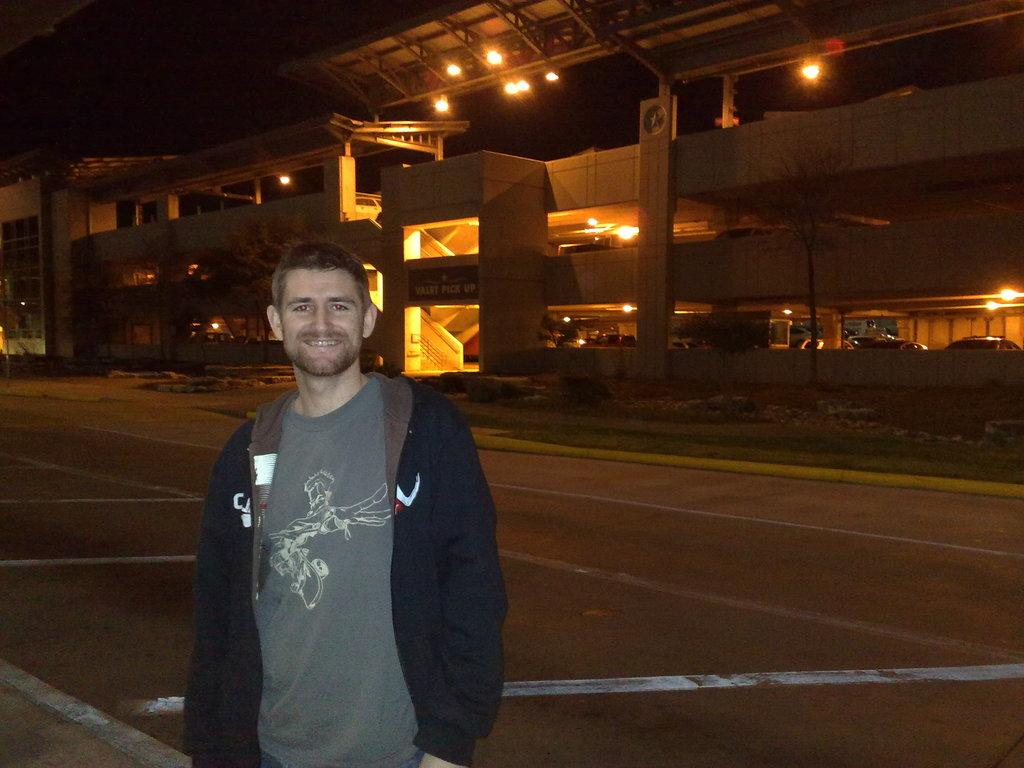What is the man in the image doing? The man is standing in the image and smiling. What can be found inside the building in the image? There are vehicles inside the building. What can be seen in the image that provides illumination? There are lights visible in the image. What type of natural elements are present in the image? There are trees in the image. What type of man-made structure is visible in the image? There is a road in the image. How would you describe the overall lighting conditions in the image? The background of the image is dark. What type of cracker is the man holding in the image? There is no cracker present in the image; the man is simply standing and smiling. What type of operation is being performed on the trees in the image? There is no operation being performed on the trees in the image; they are simply standing in the background. How many crows can be seen perched on the vehicles in the image? There are no crows present in the image; the vehicles are inside a building. 